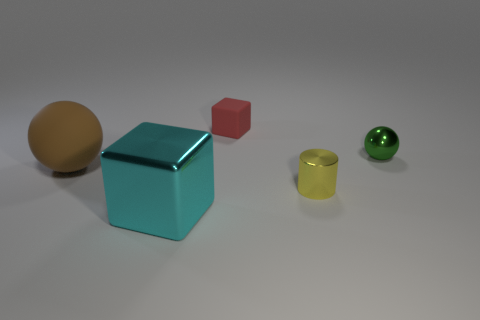Add 2 small purple shiny spheres. How many objects exist? 7 Subtract all blocks. How many objects are left? 3 Add 2 red things. How many red things exist? 3 Subtract 0 cyan cylinders. How many objects are left? 5 Subtract all large shiny cubes. Subtract all tiny yellow matte cubes. How many objects are left? 4 Add 1 green metallic spheres. How many green metallic spheres are left? 2 